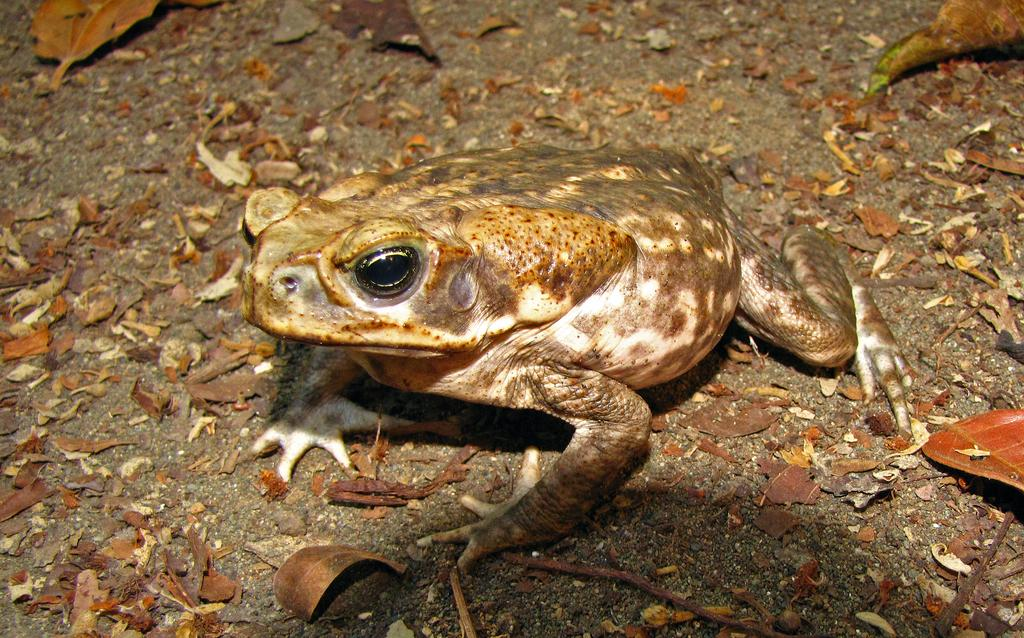What animal is present in the image? There is a frog in the image. Where is the frog located? The frog is on the land. What is covering the frog in the image? There are dried leaves on the frog. What day of the week is depicted in the image? The image does not depict a day of the week; it features a frog on the land with dried leaves on it. 